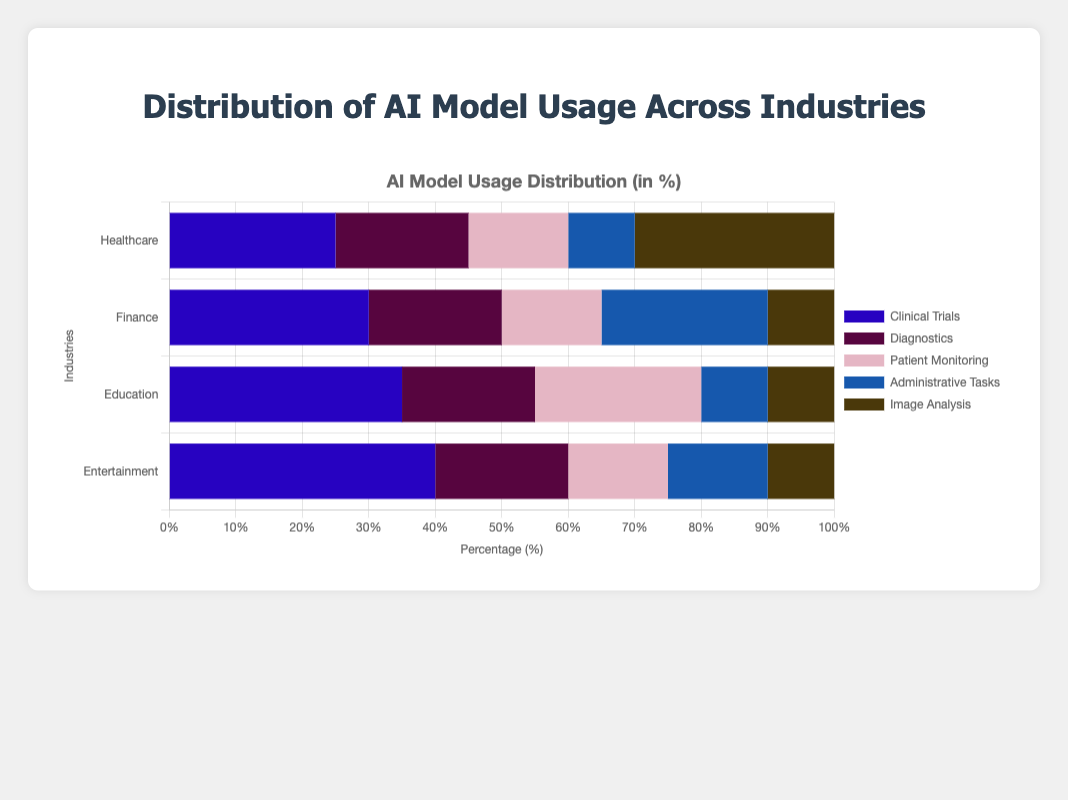Which industry has the highest percentage usage in a single subcategory? The chart shows the percentages for each subcategory within each industry. The highest single subcategory percentage is 40% for Content Recommendation within the Entertainment industry.
Answer: Entertainment Which industry has the most even distribution of AI model usage across its subcategories? Evaluating the distribution by looking for industries where the usage percentages in all subcategories are more uniform, we see that Finance has percentages of 30, 20, 15, 25, and 10, showing a more balanced distribution compared to others.
Answer: Finance In the Healthcare industry, which subcategory has the second highest percentage usage? In the Healthcare industry, the subcategory percentages are 25 for Clinical Trials, 20 for Diagnostics, 15 for Patient Monitoring, 10 for Administrative Tasks, and 30 for Image Analysis. The second highest is Clinical Trials with 25%.
Answer: Clinical Trials Which industry has the highest total percentage usage across all of its subcategories? To determine this, sum the percentages for each industry: Healthcare (25+20+15+10+30 = 100), Finance (30+20+15+25+10 = 100), Education (35+20+25+10+10 = 100), and Entertainment (40+20+15+15+10 = 100). All industries have the same total percentage usage of 100%.
Answer: All industries equally Compare the usage percentages for Personalized Learning in Education and Fraud Detection in Finance. Which is higher? The chart shows Personalized Learning in Education at 35% and Fraud Detection in Finance at 30%. Personalized Learning is higher.
Answer: Personalized Learning What subcategory has the lowest percentage usage in the Entertainment industry? In the Entertainment industry, the percentages are 40 for Content Recommendation, 20 for Game Development, 15 for Video Production, 15 for Music Composition, and 10 for Customer Analytics. The lowest is Customer Analytics with 10%.
Answer: Customer Analytics Calculate the average percentage usage of AI models across the subcategories in the Education industry. The subcategories in Education have percentages of 35, 20, 25, 10, and 10. To find the average: (35+20+25+10+10)/5 = 100/5 = 20
Answer: 20 Which subcategory in the Finance industry has double the percentage usage compared to Predictive Analytics in Education? Predictive Analytics in Education is 10%. In the Finance industry, double this would be 20%, which matches the percentage for Algorithmic Trading.
Answer: Algorithmic Trading Compare the percentage usage of Diagnostics in Healthcare and Video Production in Entertainment. Which is higher? Diagnostics in Healthcare has 20% and Video Production in Entertainment has 15%. Diagnostics in Healthcare is higher.
Answer: Diagnostics 